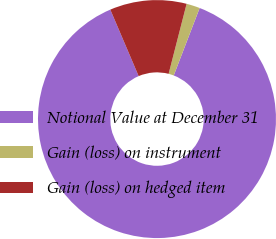Convert chart. <chart><loc_0><loc_0><loc_500><loc_500><pie_chart><fcel>Notional Value at December 31<fcel>Gain (loss) on instrument<fcel>Gain (loss) on hedged item<nl><fcel>87.75%<fcel>1.83%<fcel>10.42%<nl></chart> 